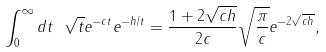<formula> <loc_0><loc_0><loc_500><loc_500>\int _ { 0 } ^ { \infty } d t \ \sqrt { t } e ^ { - c t } e ^ { - h / t } = \frac { 1 + 2 \sqrt { c h } } { 2 c } \sqrt { \frac { \pi } { c } } e ^ { - 2 \sqrt { c h } } ,</formula> 